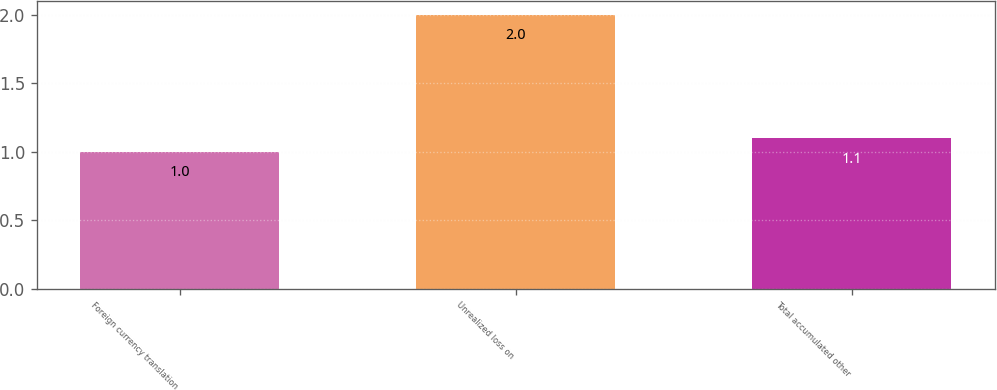<chart> <loc_0><loc_0><loc_500><loc_500><bar_chart><fcel>Foreign currency translation<fcel>Unrealized loss on<fcel>Total accumulated other<nl><fcel>1<fcel>2<fcel>1.1<nl></chart> 